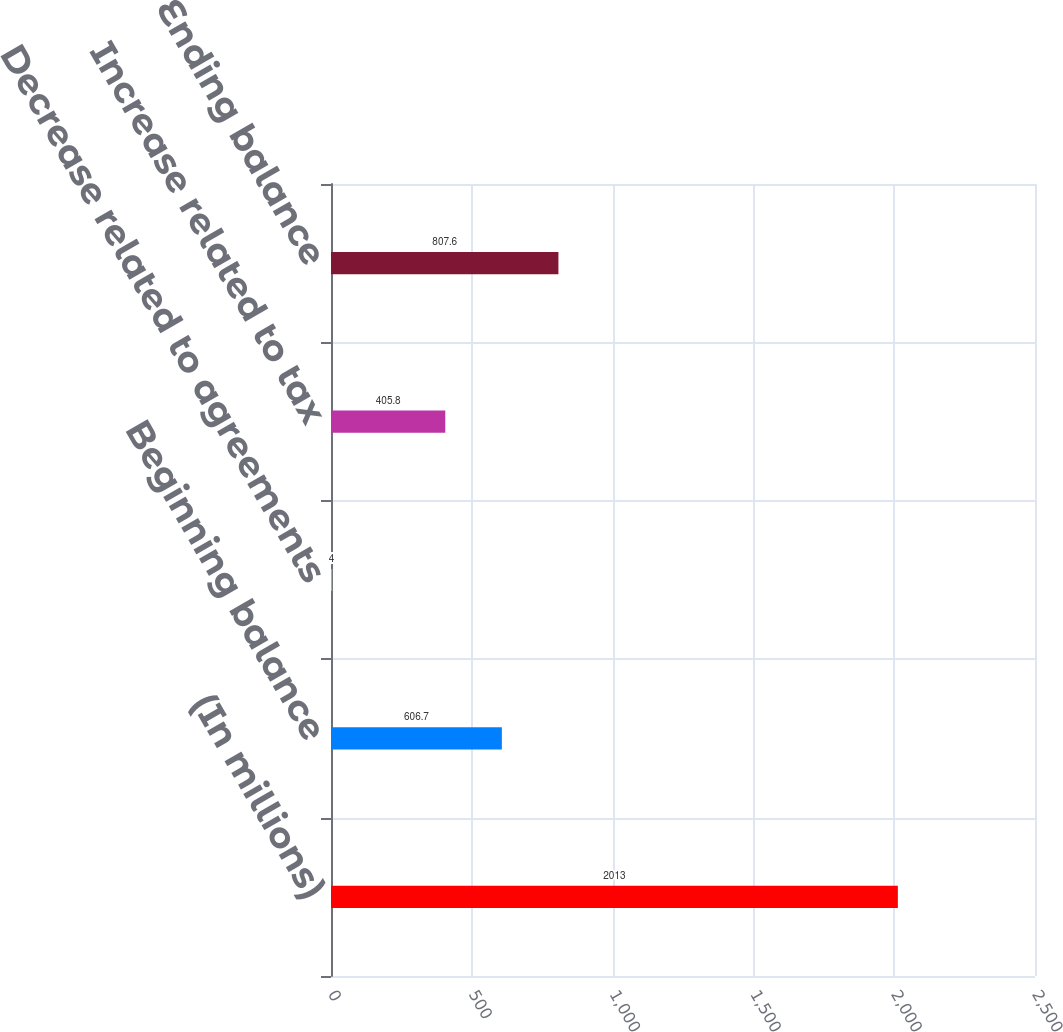Convert chart to OTSL. <chart><loc_0><loc_0><loc_500><loc_500><bar_chart><fcel>(In millions)<fcel>Beginning balance<fcel>Decrease related to agreements<fcel>Increase related to tax<fcel>Ending balance<nl><fcel>2013<fcel>606.7<fcel>4<fcel>405.8<fcel>807.6<nl></chart> 